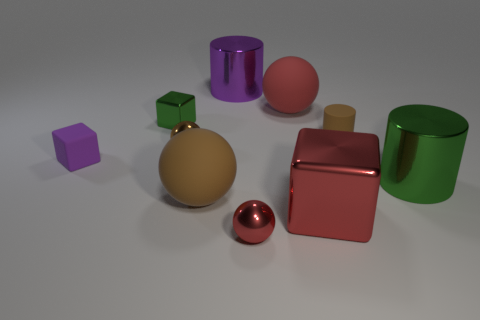Subtract all brown matte balls. How many balls are left? 3 Subtract 3 balls. How many balls are left? 1 Subtract all blue cylinders. How many yellow balls are left? 0 Subtract all purple cylinders. How many cylinders are left? 2 Subtract 1 brown cylinders. How many objects are left? 9 Subtract all cubes. How many objects are left? 7 Subtract all red cylinders. Subtract all yellow spheres. How many cylinders are left? 3 Subtract all small gray cubes. Subtract all large red metallic blocks. How many objects are left? 9 Add 2 rubber spheres. How many rubber spheres are left? 4 Add 3 purple rubber cubes. How many purple rubber cubes exist? 4 